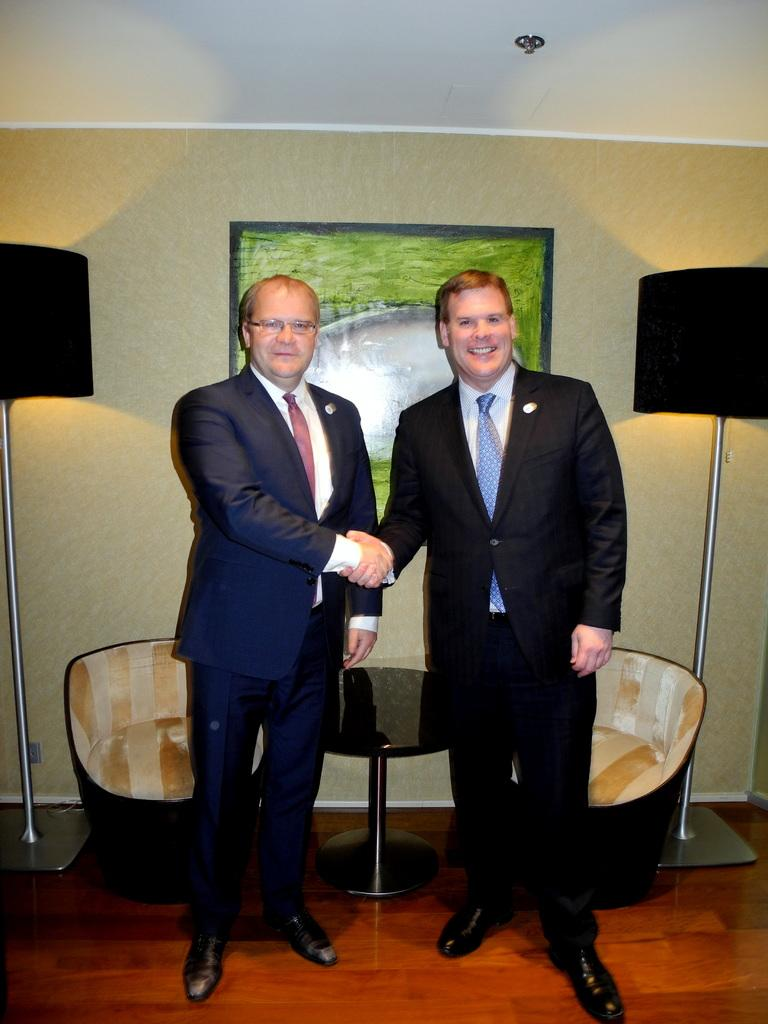What can be seen in the image regarding people? There are men standing in the image. Where are the men located in the image? The men are standing on the floor. What type of furniture is present in the image? There are chairs and a side table in the image. What decorative item can be seen on the wall? There is a wall hanging on the wall. What type of gold cast can be seen on the floor in the image? There is no gold cast present in the image; it only features men standing on the floor, chairs, a side table, and a wall hanging. 